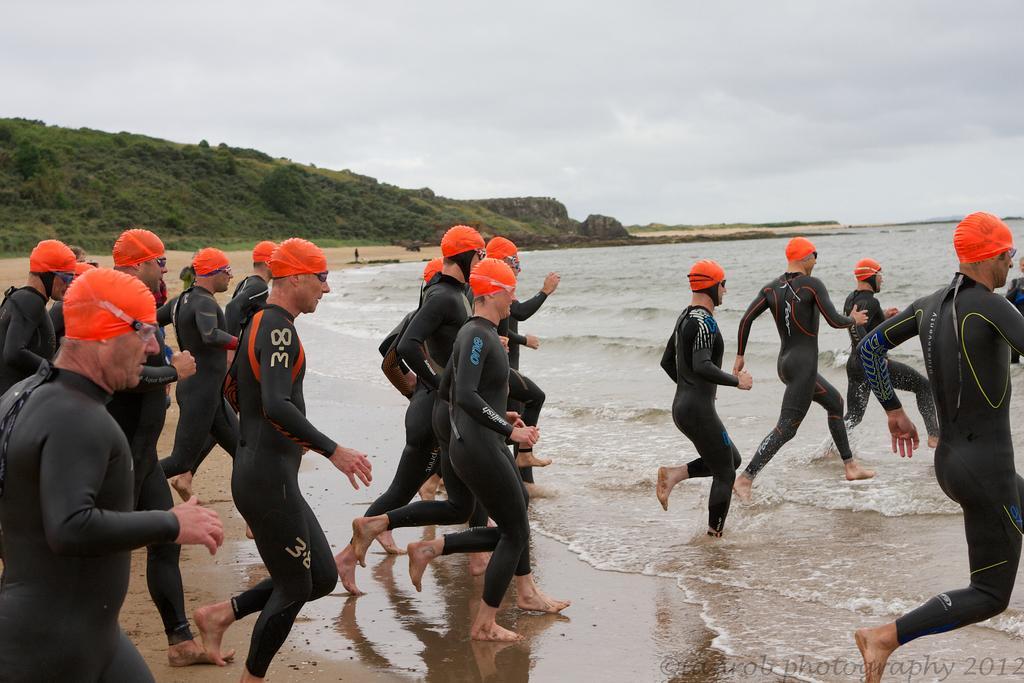Can you describe this image briefly? In this image we can see so many men are running by wearing swimming costume toward the sea. Background of the image mountain covered with grass is there and the sky is covered with clouds. 